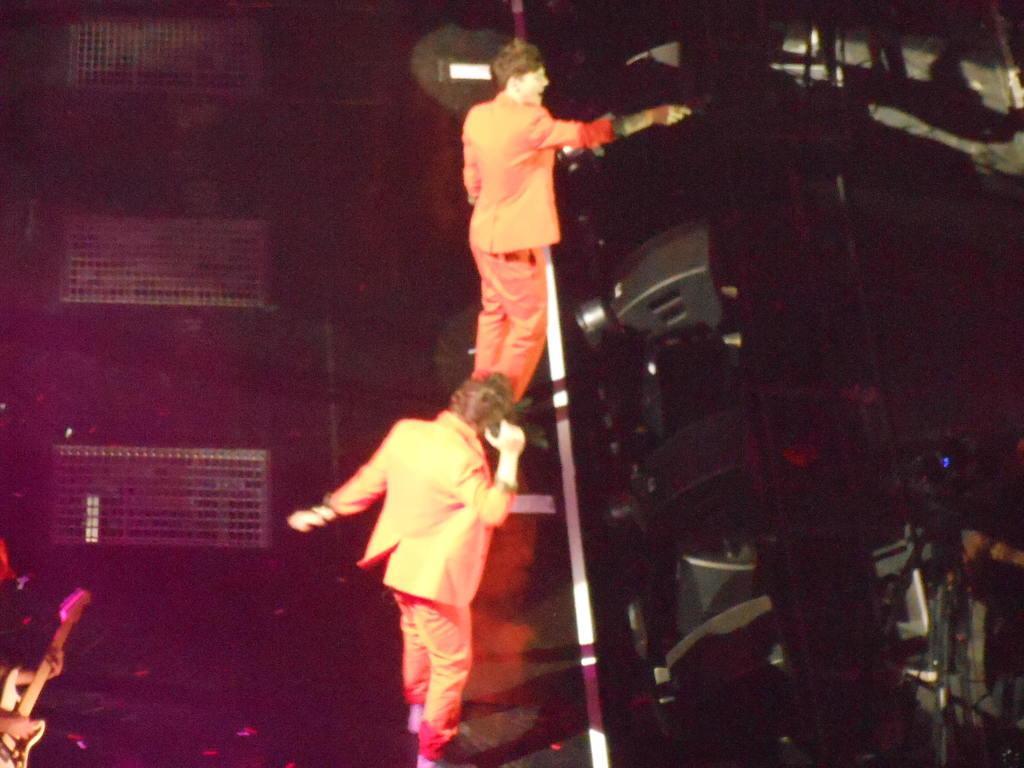In one or two sentences, can you explain what this image depicts? In the center we can see two persons were standing. On the left we can see one person holding guitar. Coming to back we can see some musical instruments around them. 